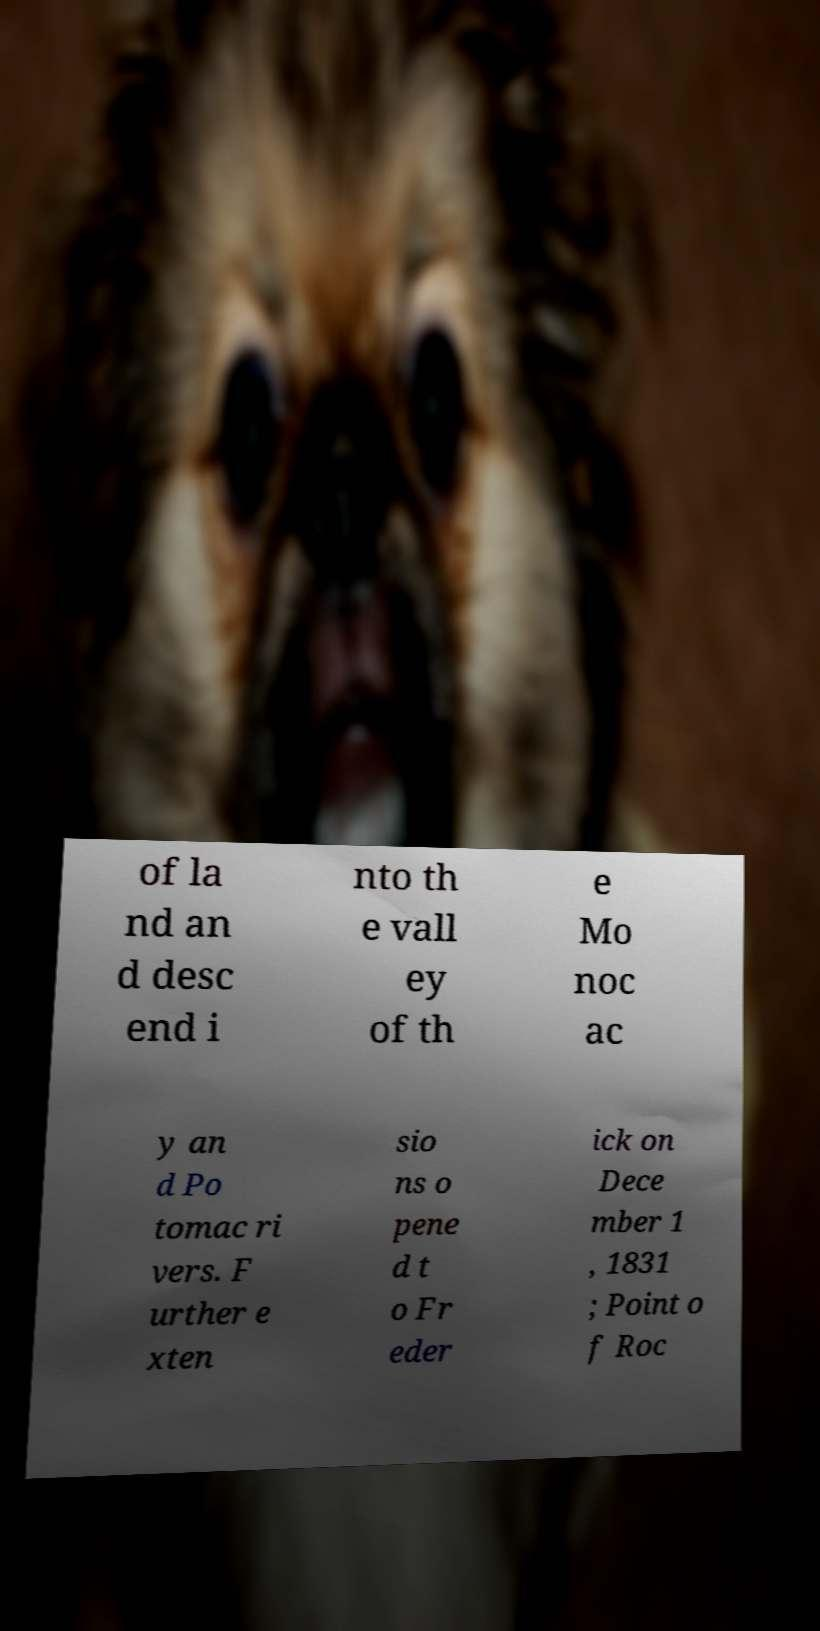I need the written content from this picture converted into text. Can you do that? of la nd an d desc end i nto th e vall ey of th e Mo noc ac y an d Po tomac ri vers. F urther e xten sio ns o pene d t o Fr eder ick on Dece mber 1 , 1831 ; Point o f Roc 